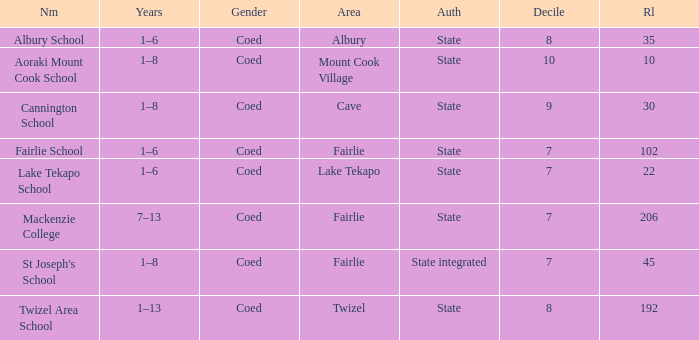What is the total Decile that has a state authority, fairlie area and roll smarter than 206? 1.0. 